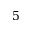<formula> <loc_0><loc_0><loc_500><loc_500>5</formula> 